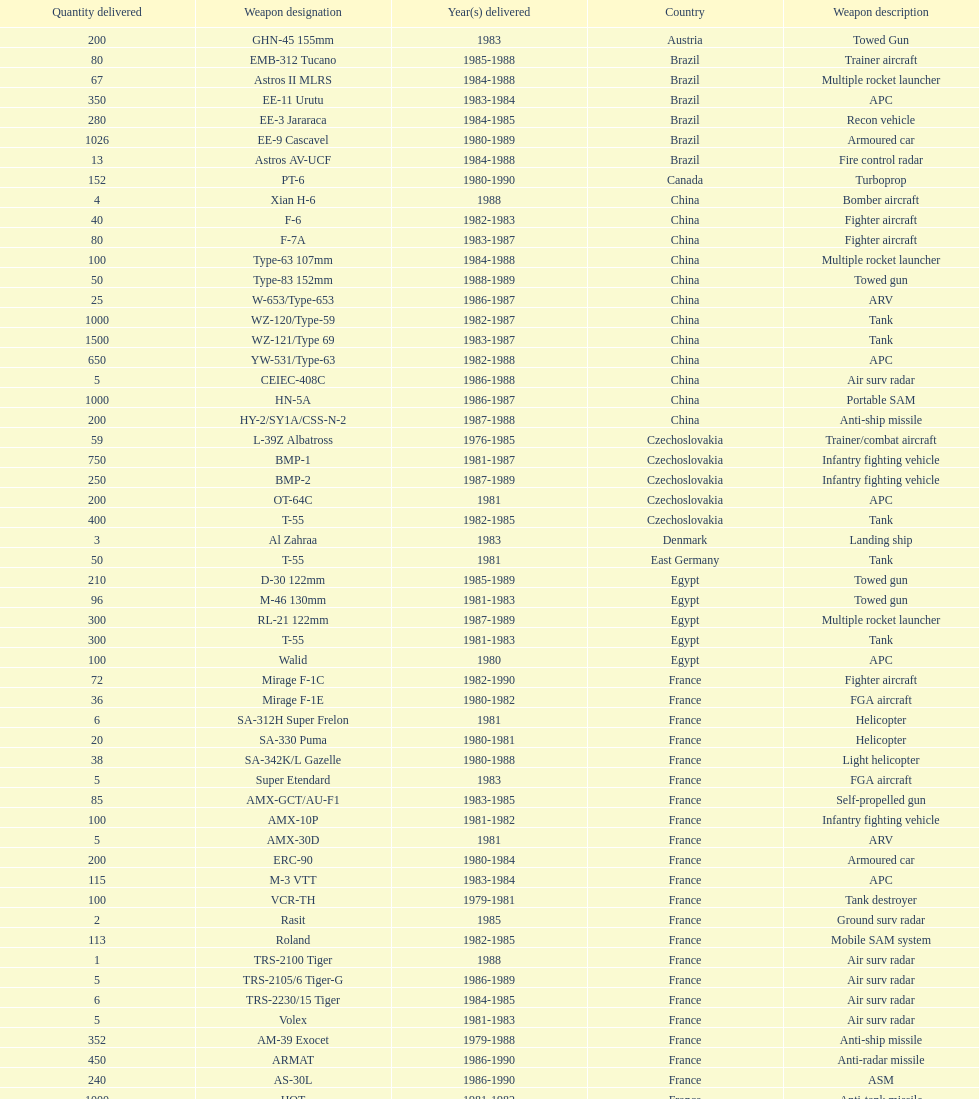Would you be able to parse every entry in this table? {'header': ['Quantity delivered', 'Weapon designation', 'Year(s) delivered', 'Country', 'Weapon description'], 'rows': [['200', 'GHN-45 155mm', '1983', 'Austria', 'Towed Gun'], ['80', 'EMB-312 Tucano', '1985-1988', 'Brazil', 'Trainer aircraft'], ['67', 'Astros II MLRS', '1984-1988', 'Brazil', 'Multiple rocket launcher'], ['350', 'EE-11 Urutu', '1983-1984', 'Brazil', 'APC'], ['280', 'EE-3 Jararaca', '1984-1985', 'Brazil', 'Recon vehicle'], ['1026', 'EE-9 Cascavel', '1980-1989', 'Brazil', 'Armoured car'], ['13', 'Astros AV-UCF', '1984-1988', 'Brazil', 'Fire control radar'], ['152', 'PT-6', '1980-1990', 'Canada', 'Turboprop'], ['4', 'Xian H-6', '1988', 'China', 'Bomber aircraft'], ['40', 'F-6', '1982-1983', 'China', 'Fighter aircraft'], ['80', 'F-7A', '1983-1987', 'China', 'Fighter aircraft'], ['100', 'Type-63 107mm', '1984-1988', 'China', 'Multiple rocket launcher'], ['50', 'Type-83 152mm', '1988-1989', 'China', 'Towed gun'], ['25', 'W-653/Type-653', '1986-1987', 'China', 'ARV'], ['1000', 'WZ-120/Type-59', '1982-1987', 'China', 'Tank'], ['1500', 'WZ-121/Type 69', '1983-1987', 'China', 'Tank'], ['650', 'YW-531/Type-63', '1982-1988', 'China', 'APC'], ['5', 'CEIEC-408C', '1986-1988', 'China', 'Air surv radar'], ['1000', 'HN-5A', '1986-1987', 'China', 'Portable SAM'], ['200', 'HY-2/SY1A/CSS-N-2', '1987-1988', 'China', 'Anti-ship missile'], ['59', 'L-39Z Albatross', '1976-1985', 'Czechoslovakia', 'Trainer/combat aircraft'], ['750', 'BMP-1', '1981-1987', 'Czechoslovakia', 'Infantry fighting vehicle'], ['250', 'BMP-2', '1987-1989', 'Czechoslovakia', 'Infantry fighting vehicle'], ['200', 'OT-64C', '1981', 'Czechoslovakia', 'APC'], ['400', 'T-55', '1982-1985', 'Czechoslovakia', 'Tank'], ['3', 'Al Zahraa', '1983', 'Denmark', 'Landing ship'], ['50', 'T-55', '1981', 'East Germany', 'Tank'], ['210', 'D-30 122mm', '1985-1989', 'Egypt', 'Towed gun'], ['96', 'M-46 130mm', '1981-1983', 'Egypt', 'Towed gun'], ['300', 'RL-21 122mm', '1987-1989', 'Egypt', 'Multiple rocket launcher'], ['300', 'T-55', '1981-1983', 'Egypt', 'Tank'], ['100', 'Walid', '1980', 'Egypt', 'APC'], ['72', 'Mirage F-1C', '1982-1990', 'France', 'Fighter aircraft'], ['36', 'Mirage F-1E', '1980-1982', 'France', 'FGA aircraft'], ['6', 'SA-312H Super Frelon', '1981', 'France', 'Helicopter'], ['20', 'SA-330 Puma', '1980-1981', 'France', 'Helicopter'], ['38', 'SA-342K/L Gazelle', '1980-1988', 'France', 'Light helicopter'], ['5', 'Super Etendard', '1983', 'France', 'FGA aircraft'], ['85', 'AMX-GCT/AU-F1', '1983-1985', 'France', 'Self-propelled gun'], ['100', 'AMX-10P', '1981-1982', 'France', 'Infantry fighting vehicle'], ['5', 'AMX-30D', '1981', 'France', 'ARV'], ['200', 'ERC-90', '1980-1984', 'France', 'Armoured car'], ['115', 'M-3 VTT', '1983-1984', 'France', 'APC'], ['100', 'VCR-TH', '1979-1981', 'France', 'Tank destroyer'], ['2', 'Rasit', '1985', 'France', 'Ground surv radar'], ['113', 'Roland', '1982-1985', 'France', 'Mobile SAM system'], ['1', 'TRS-2100 Tiger', '1988', 'France', 'Air surv radar'], ['5', 'TRS-2105/6 Tiger-G', '1986-1989', 'France', 'Air surv radar'], ['6', 'TRS-2230/15 Tiger', '1984-1985', 'France', 'Air surv radar'], ['5', 'Volex', '1981-1983', 'France', 'Air surv radar'], ['352', 'AM-39 Exocet', '1979-1988', 'France', 'Anti-ship missile'], ['450', 'ARMAT', '1986-1990', 'France', 'Anti-radar missile'], ['240', 'AS-30L', '1986-1990', 'France', 'ASM'], ['1000', 'HOT', '1981-1982', 'France', 'Anti-tank missile'], ['534', 'R-550 Magic-1', '1981-1985', 'France', 'SRAAM'], ['2260', 'Roland-2', '1981-1990', 'France', 'SAM'], ['300', 'Super 530F', '1981-1985', 'France', 'BVRAAM'], ['22', 'BK-117', '1984-1989', 'West Germany', 'Helicopter'], ['20', 'Bo-105C', '1979-1982', 'West Germany', 'Light Helicopter'], ['6', 'Bo-105L', '1988', 'West Germany', 'Light Helicopter'], ['300', 'PSZH-D-994', '1981', 'Hungary', 'APC'], ['2', 'A-109 Hirundo', '1982', 'Italy', 'Light Helicopter'], ['6', 'S-61', '1982', 'Italy', 'Helicopter'], ['1', 'Stromboli class', '1981', 'Italy', 'Support ship'], ['2', 'S-76 Spirit', '1985', 'Jordan', 'Helicopter'], ['15', 'Mi-2/Hoplite', '1984-1985', 'Poland', 'Helicopter'], ['750', 'MT-LB', '1983-1990', 'Poland', 'APC'], ['400', 'T-55', '1981-1982', 'Poland', 'Tank'], ['500', 'T-72M1', '1982-1990', 'Poland', 'Tank'], ['150', 'T-55', '1982-1984', 'Romania', 'Tank'], ['2', 'M-87 Orkan 262mm', '1988', 'Yugoslavia', 'Multiple rocket launcher'], ['200', 'G-5 155mm', '1985-1988', 'South Africa', 'Towed gun'], ['52', 'PC-7 Turbo trainer', '1980-1983', 'Switzerland', 'Trainer aircraft'], ['20', 'PC-9', '1987-1990', 'Switzerland', 'Trainer aircraft'], ['100', 'Roland', '1981', 'Switzerland', 'APC/IFV'], ['29', 'Chieftain/ARV', '1982', 'United Kingdom', 'ARV'], ['10', 'Cymbeline', '1986-1988', 'United Kingdom', 'Arty locating radar'], ['30', 'MD-500MD Defender', '1983', 'United States', 'Light Helicopter'], ['30', 'Hughes-300/TH-55', '1983', 'United States', 'Light Helicopter'], ['26', 'MD-530F', '1986', 'United States', 'Light Helicopter'], ['31', 'Bell 214ST', '1988', 'United States', 'Helicopter'], ['33', 'Il-76M/Candid-B', '1978-1984', 'Soviet Union', 'Strategic airlifter'], ['12', 'Mi-24D/Mi-25/Hind-D', '1978-1984', 'Soviet Union', 'Attack helicopter'], ['37', 'Mi-8/Mi-17/Hip-H', '1986-1987', 'Soviet Union', 'Transport helicopter'], ['30', 'Mi-8TV/Hip-F', '1984', 'Soviet Union', 'Transport helicopter'], ['61', 'Mig-21bis/Fishbed-N', '1983-1984', 'Soviet Union', 'Fighter aircraft'], ['50', 'Mig-23BN/Flogger-H', '1984-1985', 'Soviet Union', 'FGA aircraft'], ['55', 'Mig-25P/Foxbat-A', '1980-1985', 'Soviet Union', 'Interceptor aircraft'], ['8', 'Mig-25RB/Foxbat-B', '1982', 'Soviet Union', 'Recon aircraft'], ['41', 'Mig-29/Fulcrum-A', '1986-1989', 'Soviet Union', 'Fighter aircraft'], ['61', 'Su-22/Fitter-H/J/K', '1986-1987', 'Soviet Union', 'FGA aircraft'], ['84', 'Su-25/Frogfoot-A', '1986-1987', 'Soviet Union', 'Ground attack aircraft'], ['180', '2A36 152mm', '1986-1988', 'Soviet Union', 'Towed gun'], ['150', '2S1 122mm', '1980-1989', 'Soviet Union', 'Self-Propelled Howitzer'], ['150', '2S3 152mm', '1980-1989', 'Soviet Union', 'Self-propelled gun'], ['10', '2S4 240mm', '1983', 'Soviet Union', 'Self-propelled mortar'], ['10', '9P117/SS-1 Scud TEL', '1983-1984', 'Soviet Union', 'SSM launcher'], ['560', 'BM-21 Grad 122mm', '1983-1988', 'Soviet Union', 'Multiple rocket launcher'], ['576', 'D-30 122mm', '1982-1988', 'Soviet Union', 'Towed gun'], ['25', 'M-240 240mm', '1981', 'Soviet Union', 'Mortar'], ['576', 'M-46 130mm', '1982-1987', 'Soviet Union', 'Towed Gun'], ['30', '9K35 Strela-10/SA-13', '1985', 'Soviet Union', 'AAV(M)'], ['10', 'BMD-1', '1981', 'Soviet Union', 'IFV'], ['200', 'PT-76', '1984', 'Soviet Union', 'Light tank'], ['160', 'SA-9/9P31', '1982-1985', 'Soviet Union', 'AAV(M)'], ['10', 'Long Track', '1980-1984', 'Soviet Union', 'Air surv radar'], ['50', 'SA-8b/9K33M Osa AK', '1982-1985', 'Soviet Union', 'Mobile SAM system'], ['5', 'Thin Skin', '1980-1984', 'Soviet Union', 'Air surv radar'], ['3000', '9M111/AT-4 Spigot', '1986-1989', 'Soviet Union', 'Anti-tank missile'], ['960', '9M37/SA-13 Gopher', '1985-1986', 'Soviet Union', 'SAM'], ['36', 'KSR-5/AS-6 Kingfish', '1984', 'Soviet Union', 'Anti-ship missile'], ['250', 'Kh-28/AS-9 Kyle', '1983-1988', 'Soviet Union', 'Anti-radar missile'], ['1080', 'R-13S/AA2S Atoll', '1984-1987', 'Soviet Union', 'SRAAM'], ['840', 'R-17/SS-1c Scud-B', '1982-1988', 'Soviet Union', 'SSM'], ['246', 'R-27/AA-10 Alamo', '1986-1989', 'Soviet Union', 'BVRAAM'], ['660', 'R-40R/AA-6 Acrid', '1980-1985', 'Soviet Union', 'BVRAAM'], ['582', 'R-60/AA-8 Aphid', '1986-1989', 'Soviet Union', 'SRAAM'], ['1290', 'SA-8b Gecko/9M33M', '1982-1985', 'Soviet Union', 'SAM'], ['1920', 'SA-9 Gaskin/9M31', '1982-1985', 'Soviet Union', 'SAM'], ['500', 'Strela-3/SA-14 Gremlin', '1987-1988', 'Soviet Union', 'Portable SAM']]} According to this list, how many countries sold weapons to iraq? 21. 